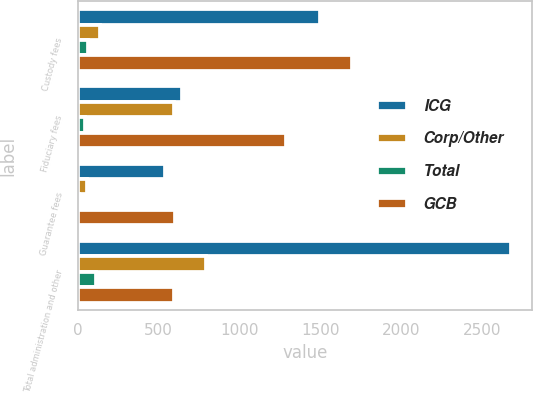Convert chart to OTSL. <chart><loc_0><loc_0><loc_500><loc_500><stacked_bar_chart><ecel><fcel>Custody fees<fcel>Fiduciary fees<fcel>Guarantee fees<fcel>Total administration and other<nl><fcel>ICG<fcel>1494<fcel>645<fcel>536<fcel>2675<nl><fcel>Corp/Other<fcel>136<fcel>597<fcel>57<fcel>790<nl><fcel>Total<fcel>65<fcel>43<fcel>7<fcel>115<nl><fcel>GCB<fcel>1695<fcel>1285<fcel>600<fcel>597<nl></chart> 